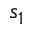<formula> <loc_0><loc_0><loc_500><loc_500>s _ { 1 }</formula> 